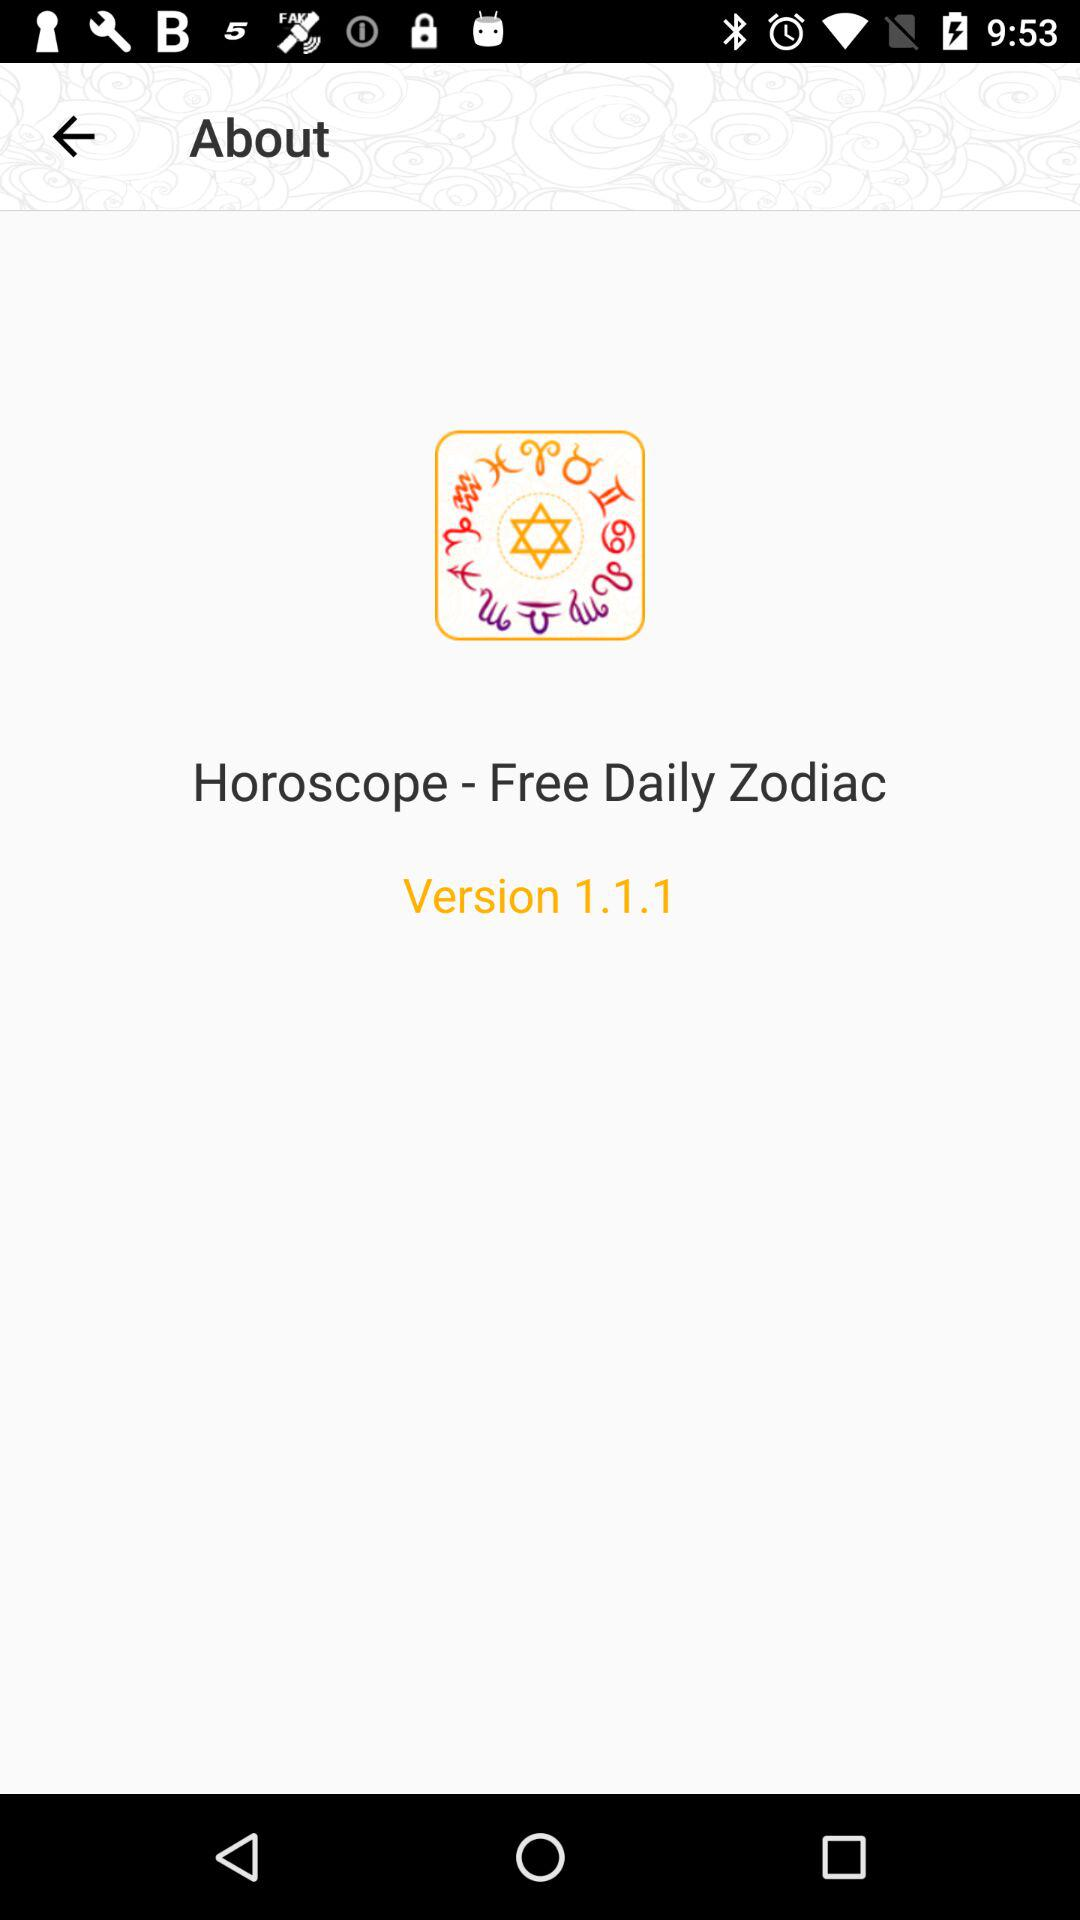What is the version of the app? The version is 1.1.1. 